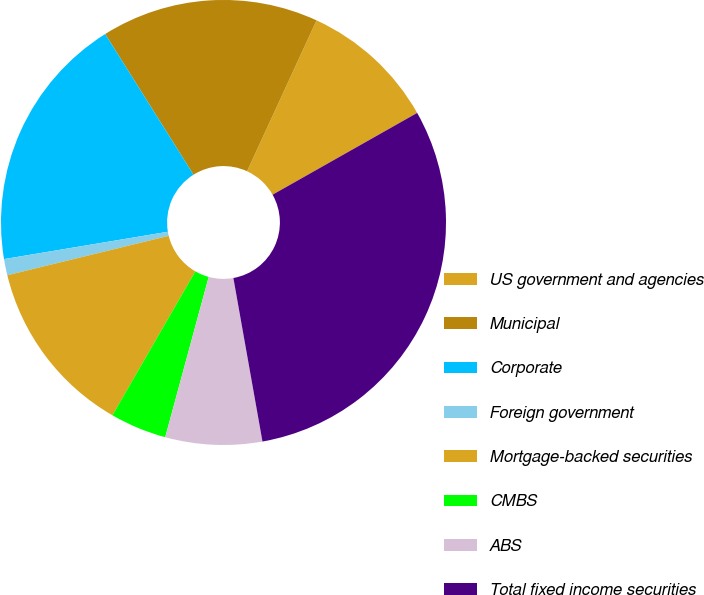<chart> <loc_0><loc_0><loc_500><loc_500><pie_chart><fcel>US government and agencies<fcel>Municipal<fcel>Corporate<fcel>Foreign government<fcel>Mortgage-backed securities<fcel>CMBS<fcel>ABS<fcel>Total fixed income securities<nl><fcel>9.94%<fcel>15.79%<fcel>18.71%<fcel>1.18%<fcel>12.87%<fcel>4.1%<fcel>7.02%<fcel>30.39%<nl></chart> 